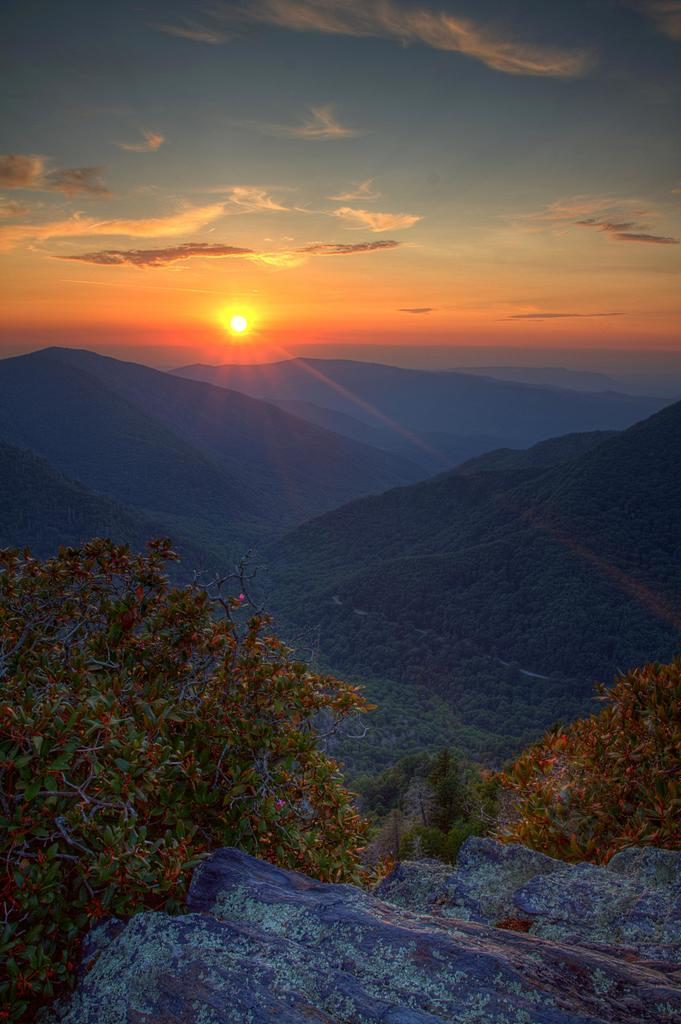What is located at the bottom of the image? There is a rock at the bottom of the image. What is behind the rock in the image? There are trees behind the rock. What is visible behind the trees in the image? There are hills behind the trees. What can be seen in the sky in the image? The sky is visible at the top of the image, and there are clouds and the sun in the sky. What type of zipper can be seen on the rock in the image? There is no zipper present on the rock in the image. What rhythm is the sun following in the image? The sun does not follow a rhythm in the image; it is a celestial body that appears to be stationary in the sky. 